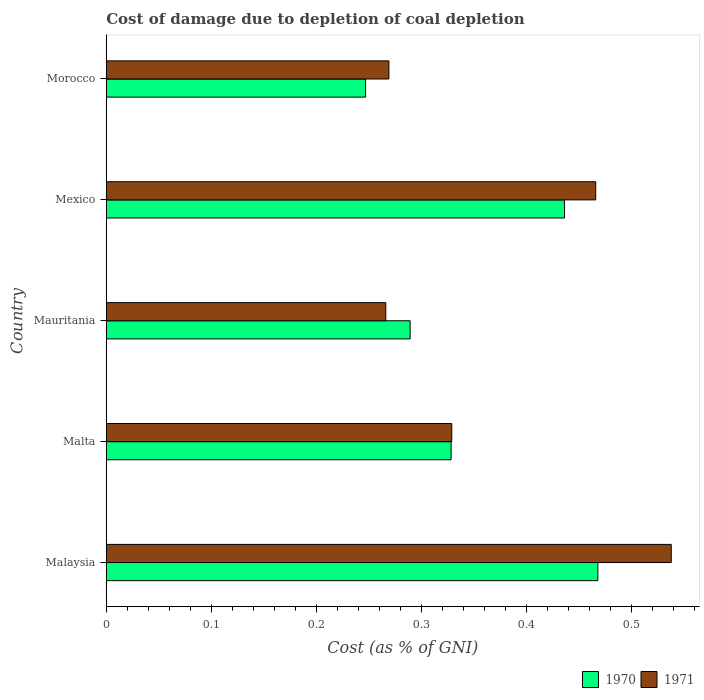How many groups of bars are there?
Your answer should be very brief. 5. Are the number of bars per tick equal to the number of legend labels?
Offer a very short reply. Yes. How many bars are there on the 4th tick from the top?
Provide a short and direct response. 2. How many bars are there on the 5th tick from the bottom?
Keep it short and to the point. 2. What is the label of the 4th group of bars from the top?
Your response must be concise. Malta. What is the cost of damage caused due to coal depletion in 1970 in Mauritania?
Keep it short and to the point. 0.29. Across all countries, what is the maximum cost of damage caused due to coal depletion in 1970?
Provide a short and direct response. 0.47. Across all countries, what is the minimum cost of damage caused due to coal depletion in 1971?
Offer a terse response. 0.27. In which country was the cost of damage caused due to coal depletion in 1971 maximum?
Provide a succinct answer. Malaysia. In which country was the cost of damage caused due to coal depletion in 1971 minimum?
Your answer should be very brief. Mauritania. What is the total cost of damage caused due to coal depletion in 1970 in the graph?
Keep it short and to the point. 1.77. What is the difference between the cost of damage caused due to coal depletion in 1971 in Mauritania and that in Mexico?
Offer a very short reply. -0.2. What is the difference between the cost of damage caused due to coal depletion in 1971 in Malta and the cost of damage caused due to coal depletion in 1970 in Malaysia?
Offer a very short reply. -0.14. What is the average cost of damage caused due to coal depletion in 1970 per country?
Ensure brevity in your answer.  0.35. What is the difference between the cost of damage caused due to coal depletion in 1970 and cost of damage caused due to coal depletion in 1971 in Malaysia?
Provide a succinct answer. -0.07. In how many countries, is the cost of damage caused due to coal depletion in 1970 greater than 0.5 %?
Keep it short and to the point. 0. What is the ratio of the cost of damage caused due to coal depletion in 1970 in Malaysia to that in Mexico?
Offer a terse response. 1.07. Is the cost of damage caused due to coal depletion in 1970 in Mexico less than that in Morocco?
Give a very brief answer. No. What is the difference between the highest and the second highest cost of damage caused due to coal depletion in 1970?
Your answer should be compact. 0.03. What is the difference between the highest and the lowest cost of damage caused due to coal depletion in 1970?
Make the answer very short. 0.22. In how many countries, is the cost of damage caused due to coal depletion in 1970 greater than the average cost of damage caused due to coal depletion in 1970 taken over all countries?
Offer a very short reply. 2. Is the sum of the cost of damage caused due to coal depletion in 1971 in Malta and Mauritania greater than the maximum cost of damage caused due to coal depletion in 1970 across all countries?
Your response must be concise. Yes. What does the 2nd bar from the bottom in Mexico represents?
Provide a short and direct response. 1971. How many countries are there in the graph?
Offer a very short reply. 5. What is the difference between two consecutive major ticks on the X-axis?
Make the answer very short. 0.1. Where does the legend appear in the graph?
Keep it short and to the point. Bottom right. How many legend labels are there?
Your answer should be very brief. 2. What is the title of the graph?
Your answer should be compact. Cost of damage due to depletion of coal depletion. Does "1961" appear as one of the legend labels in the graph?
Your answer should be compact. No. What is the label or title of the X-axis?
Keep it short and to the point. Cost (as % of GNI). What is the Cost (as % of GNI) of 1970 in Malaysia?
Your response must be concise. 0.47. What is the Cost (as % of GNI) of 1971 in Malaysia?
Offer a very short reply. 0.54. What is the Cost (as % of GNI) in 1970 in Malta?
Ensure brevity in your answer.  0.33. What is the Cost (as % of GNI) of 1971 in Malta?
Offer a terse response. 0.33. What is the Cost (as % of GNI) in 1970 in Mauritania?
Offer a terse response. 0.29. What is the Cost (as % of GNI) of 1971 in Mauritania?
Ensure brevity in your answer.  0.27. What is the Cost (as % of GNI) in 1970 in Mexico?
Your answer should be very brief. 0.44. What is the Cost (as % of GNI) of 1971 in Mexico?
Keep it short and to the point. 0.47. What is the Cost (as % of GNI) of 1970 in Morocco?
Ensure brevity in your answer.  0.25. What is the Cost (as % of GNI) in 1971 in Morocco?
Make the answer very short. 0.27. Across all countries, what is the maximum Cost (as % of GNI) in 1970?
Your answer should be very brief. 0.47. Across all countries, what is the maximum Cost (as % of GNI) of 1971?
Offer a very short reply. 0.54. Across all countries, what is the minimum Cost (as % of GNI) in 1970?
Ensure brevity in your answer.  0.25. Across all countries, what is the minimum Cost (as % of GNI) of 1971?
Your answer should be very brief. 0.27. What is the total Cost (as % of GNI) in 1970 in the graph?
Your response must be concise. 1.77. What is the total Cost (as % of GNI) in 1971 in the graph?
Keep it short and to the point. 1.87. What is the difference between the Cost (as % of GNI) of 1970 in Malaysia and that in Malta?
Make the answer very short. 0.14. What is the difference between the Cost (as % of GNI) of 1971 in Malaysia and that in Malta?
Give a very brief answer. 0.21. What is the difference between the Cost (as % of GNI) of 1970 in Malaysia and that in Mauritania?
Give a very brief answer. 0.18. What is the difference between the Cost (as % of GNI) in 1971 in Malaysia and that in Mauritania?
Ensure brevity in your answer.  0.27. What is the difference between the Cost (as % of GNI) of 1970 in Malaysia and that in Mexico?
Offer a terse response. 0.03. What is the difference between the Cost (as % of GNI) of 1971 in Malaysia and that in Mexico?
Make the answer very short. 0.07. What is the difference between the Cost (as % of GNI) of 1970 in Malaysia and that in Morocco?
Your answer should be compact. 0.22. What is the difference between the Cost (as % of GNI) in 1971 in Malaysia and that in Morocco?
Your response must be concise. 0.27. What is the difference between the Cost (as % of GNI) of 1970 in Malta and that in Mauritania?
Ensure brevity in your answer.  0.04. What is the difference between the Cost (as % of GNI) of 1971 in Malta and that in Mauritania?
Your answer should be compact. 0.06. What is the difference between the Cost (as % of GNI) of 1970 in Malta and that in Mexico?
Provide a succinct answer. -0.11. What is the difference between the Cost (as % of GNI) of 1971 in Malta and that in Mexico?
Your answer should be very brief. -0.14. What is the difference between the Cost (as % of GNI) in 1970 in Malta and that in Morocco?
Keep it short and to the point. 0.08. What is the difference between the Cost (as % of GNI) of 1971 in Malta and that in Morocco?
Ensure brevity in your answer.  0.06. What is the difference between the Cost (as % of GNI) of 1970 in Mauritania and that in Mexico?
Give a very brief answer. -0.15. What is the difference between the Cost (as % of GNI) of 1971 in Mauritania and that in Mexico?
Provide a succinct answer. -0.2. What is the difference between the Cost (as % of GNI) in 1970 in Mauritania and that in Morocco?
Provide a succinct answer. 0.04. What is the difference between the Cost (as % of GNI) of 1971 in Mauritania and that in Morocco?
Keep it short and to the point. -0. What is the difference between the Cost (as % of GNI) in 1970 in Mexico and that in Morocco?
Offer a terse response. 0.19. What is the difference between the Cost (as % of GNI) of 1971 in Mexico and that in Morocco?
Make the answer very short. 0.2. What is the difference between the Cost (as % of GNI) of 1970 in Malaysia and the Cost (as % of GNI) of 1971 in Malta?
Your response must be concise. 0.14. What is the difference between the Cost (as % of GNI) of 1970 in Malaysia and the Cost (as % of GNI) of 1971 in Mauritania?
Provide a succinct answer. 0.2. What is the difference between the Cost (as % of GNI) in 1970 in Malaysia and the Cost (as % of GNI) in 1971 in Mexico?
Offer a very short reply. 0. What is the difference between the Cost (as % of GNI) of 1970 in Malaysia and the Cost (as % of GNI) of 1971 in Morocco?
Your response must be concise. 0.2. What is the difference between the Cost (as % of GNI) of 1970 in Malta and the Cost (as % of GNI) of 1971 in Mauritania?
Give a very brief answer. 0.06. What is the difference between the Cost (as % of GNI) in 1970 in Malta and the Cost (as % of GNI) in 1971 in Mexico?
Offer a very short reply. -0.14. What is the difference between the Cost (as % of GNI) of 1970 in Malta and the Cost (as % of GNI) of 1971 in Morocco?
Your response must be concise. 0.06. What is the difference between the Cost (as % of GNI) in 1970 in Mauritania and the Cost (as % of GNI) in 1971 in Mexico?
Offer a very short reply. -0.18. What is the difference between the Cost (as % of GNI) in 1970 in Mauritania and the Cost (as % of GNI) in 1971 in Morocco?
Keep it short and to the point. 0.02. What is the difference between the Cost (as % of GNI) of 1970 in Mexico and the Cost (as % of GNI) of 1971 in Morocco?
Your response must be concise. 0.17. What is the average Cost (as % of GNI) of 1970 per country?
Keep it short and to the point. 0.35. What is the average Cost (as % of GNI) of 1971 per country?
Your answer should be compact. 0.37. What is the difference between the Cost (as % of GNI) of 1970 and Cost (as % of GNI) of 1971 in Malaysia?
Make the answer very short. -0.07. What is the difference between the Cost (as % of GNI) in 1970 and Cost (as % of GNI) in 1971 in Malta?
Your response must be concise. -0. What is the difference between the Cost (as % of GNI) in 1970 and Cost (as % of GNI) in 1971 in Mauritania?
Provide a succinct answer. 0.02. What is the difference between the Cost (as % of GNI) of 1970 and Cost (as % of GNI) of 1971 in Mexico?
Your answer should be very brief. -0.03. What is the difference between the Cost (as % of GNI) in 1970 and Cost (as % of GNI) in 1971 in Morocco?
Your answer should be very brief. -0.02. What is the ratio of the Cost (as % of GNI) in 1970 in Malaysia to that in Malta?
Provide a succinct answer. 1.43. What is the ratio of the Cost (as % of GNI) in 1971 in Malaysia to that in Malta?
Give a very brief answer. 1.64. What is the ratio of the Cost (as % of GNI) in 1970 in Malaysia to that in Mauritania?
Offer a very short reply. 1.62. What is the ratio of the Cost (as % of GNI) in 1971 in Malaysia to that in Mauritania?
Offer a very short reply. 2.02. What is the ratio of the Cost (as % of GNI) of 1970 in Malaysia to that in Mexico?
Your response must be concise. 1.07. What is the ratio of the Cost (as % of GNI) of 1971 in Malaysia to that in Mexico?
Make the answer very short. 1.15. What is the ratio of the Cost (as % of GNI) of 1970 in Malaysia to that in Morocco?
Ensure brevity in your answer.  1.9. What is the ratio of the Cost (as % of GNI) of 1971 in Malaysia to that in Morocco?
Your answer should be compact. 2. What is the ratio of the Cost (as % of GNI) in 1970 in Malta to that in Mauritania?
Offer a very short reply. 1.13. What is the ratio of the Cost (as % of GNI) of 1971 in Malta to that in Mauritania?
Your response must be concise. 1.24. What is the ratio of the Cost (as % of GNI) in 1970 in Malta to that in Mexico?
Ensure brevity in your answer.  0.75. What is the ratio of the Cost (as % of GNI) of 1971 in Malta to that in Mexico?
Offer a very short reply. 0.71. What is the ratio of the Cost (as % of GNI) in 1970 in Malta to that in Morocco?
Your response must be concise. 1.33. What is the ratio of the Cost (as % of GNI) of 1971 in Malta to that in Morocco?
Offer a terse response. 1.22. What is the ratio of the Cost (as % of GNI) in 1970 in Mauritania to that in Mexico?
Give a very brief answer. 0.66. What is the ratio of the Cost (as % of GNI) of 1971 in Mauritania to that in Mexico?
Your response must be concise. 0.57. What is the ratio of the Cost (as % of GNI) in 1970 in Mauritania to that in Morocco?
Ensure brevity in your answer.  1.17. What is the ratio of the Cost (as % of GNI) of 1971 in Mauritania to that in Morocco?
Provide a short and direct response. 0.99. What is the ratio of the Cost (as % of GNI) of 1970 in Mexico to that in Morocco?
Offer a terse response. 1.77. What is the ratio of the Cost (as % of GNI) in 1971 in Mexico to that in Morocco?
Provide a succinct answer. 1.73. What is the difference between the highest and the second highest Cost (as % of GNI) in 1970?
Offer a terse response. 0.03. What is the difference between the highest and the second highest Cost (as % of GNI) of 1971?
Offer a very short reply. 0.07. What is the difference between the highest and the lowest Cost (as % of GNI) in 1970?
Give a very brief answer. 0.22. What is the difference between the highest and the lowest Cost (as % of GNI) of 1971?
Make the answer very short. 0.27. 